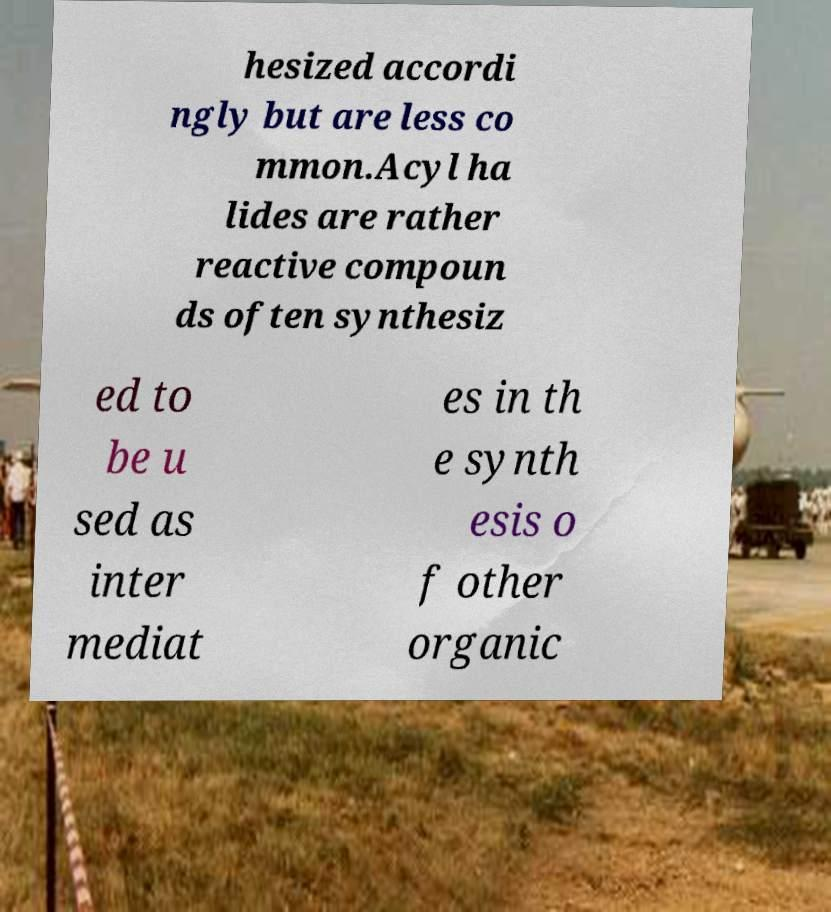Could you assist in decoding the text presented in this image and type it out clearly? hesized accordi ngly but are less co mmon.Acyl ha lides are rather reactive compoun ds often synthesiz ed to be u sed as inter mediat es in th e synth esis o f other organic 